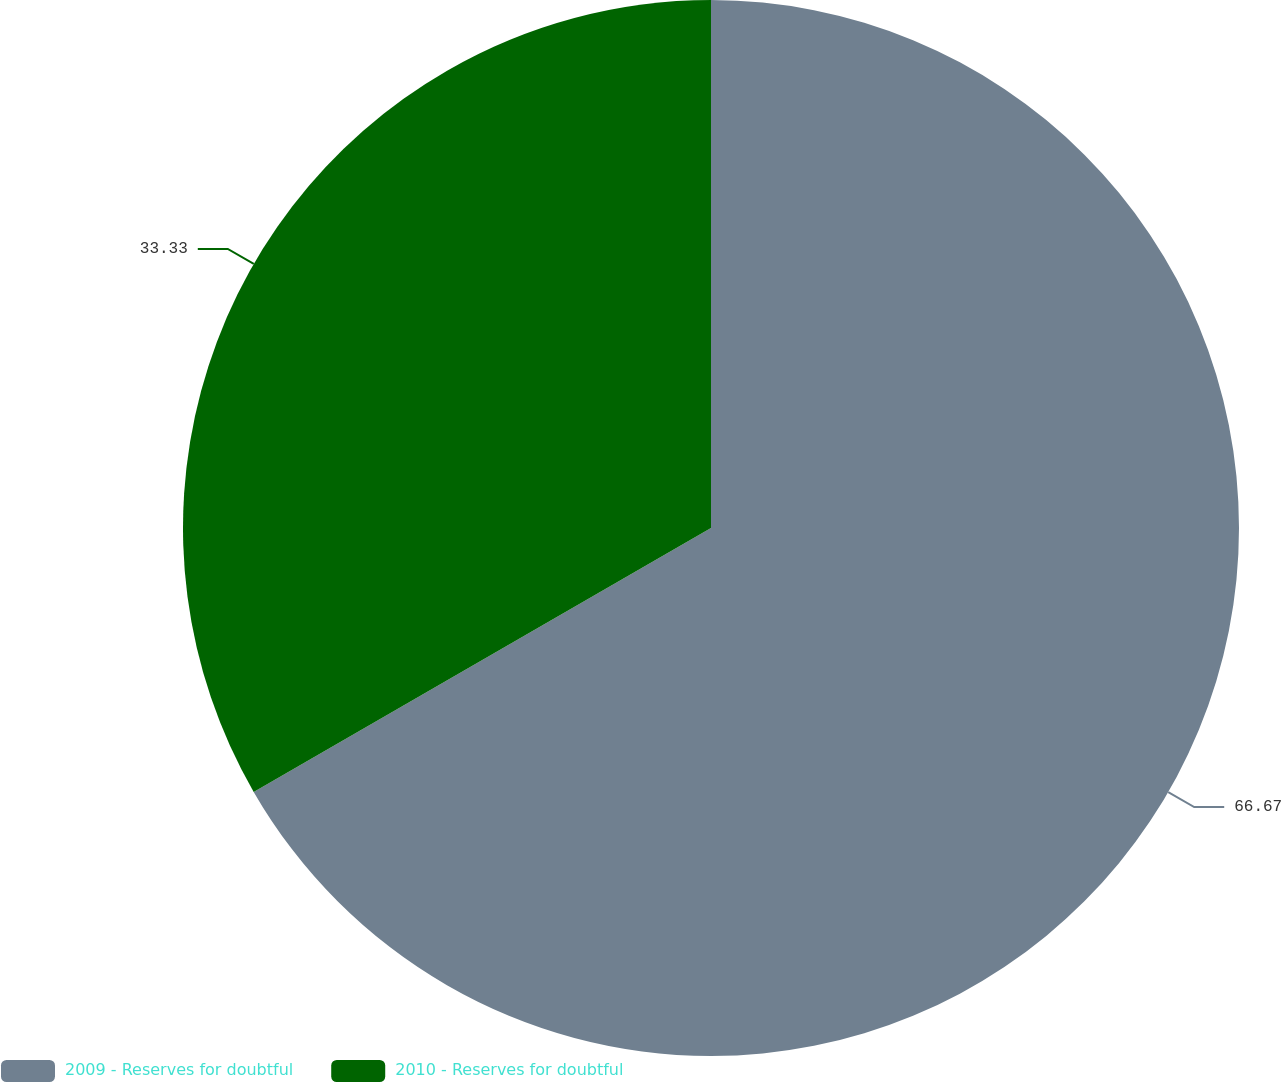<chart> <loc_0><loc_0><loc_500><loc_500><pie_chart><fcel>2009 - Reserves for doubtful<fcel>2010 - Reserves for doubtful<nl><fcel>66.67%<fcel>33.33%<nl></chart> 